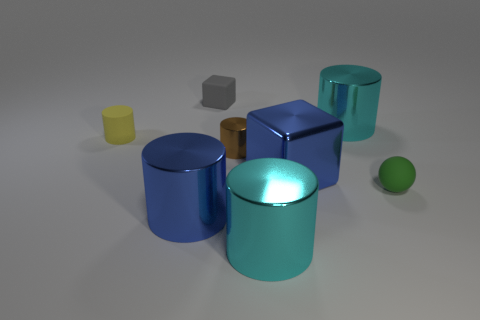How many objects are there in total, and can you describe their colors and materials? In total, there are six objects visible in the image. Starting from the left, there is a small yellow matte cylinder, a small gray matte cube, a small blue matte cylinder, a large bronze shiny cylinder, a large blue shiny cylinder, and finally, a small green rubber sphere. 